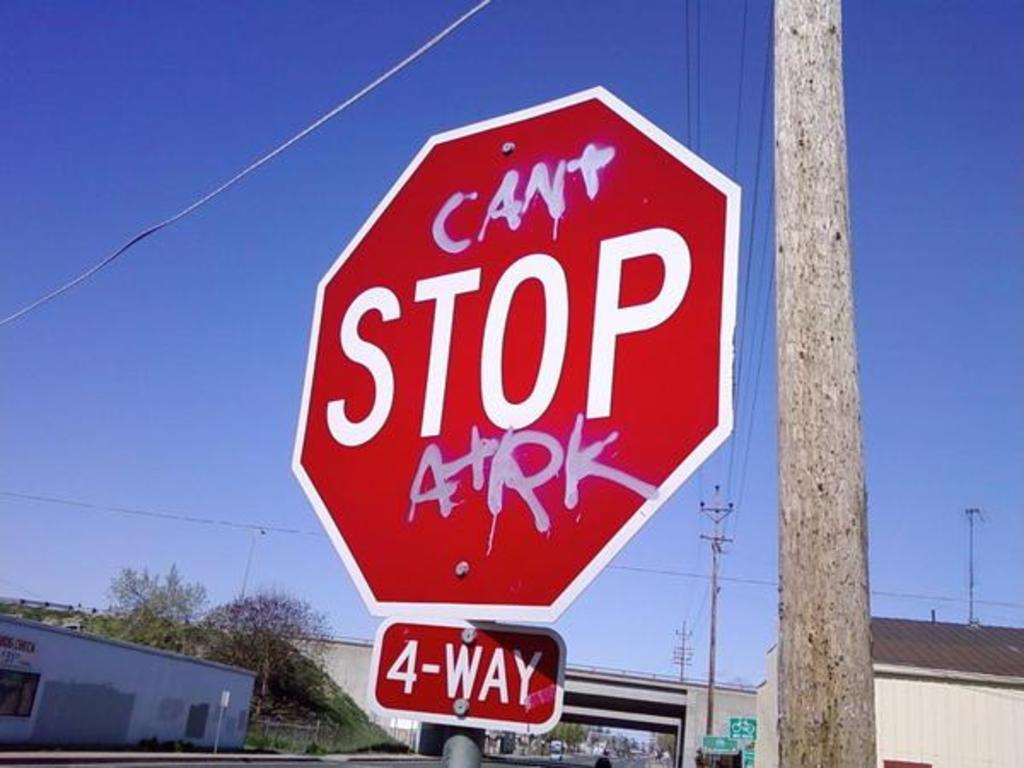<image>
Relay a brief, clear account of the picture shown. A stop sign sits atop a smaller sign reading 4-way. 